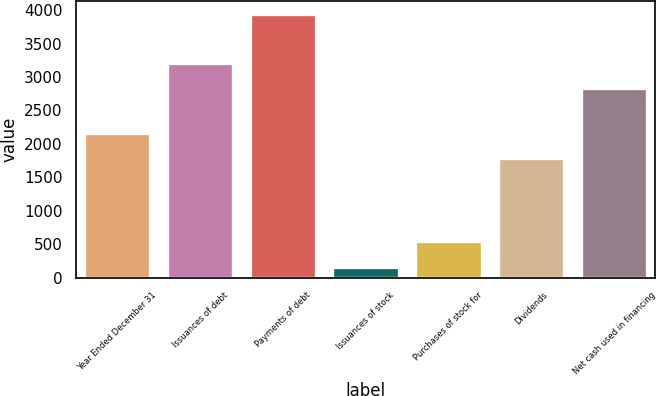Convert chart to OTSL. <chart><loc_0><loc_0><loc_500><loc_500><bar_chart><fcel>Year Ended December 31<fcel>Issuances of debt<fcel>Payments of debt<fcel>Issuances of stock<fcel>Purchases of stock for<fcel>Dividends<fcel>Net cash used in financing<nl><fcel>2168.3<fcel>3207.3<fcel>3937<fcel>164<fcel>541.3<fcel>1791<fcel>2830<nl></chart> 